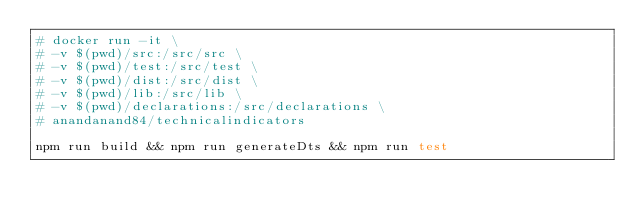Convert code to text. <code><loc_0><loc_0><loc_500><loc_500><_Bash_># docker run -it \
# -v $(pwd)/src:/src/src \
# -v $(pwd)/test:/src/test \
# -v $(pwd)/dist:/src/dist \
# -v $(pwd)/lib:/src/lib \
# -v $(pwd)/declarations:/src/declarations \
# anandanand84/technicalindicators

npm run build && npm run generateDts && npm run test</code> 